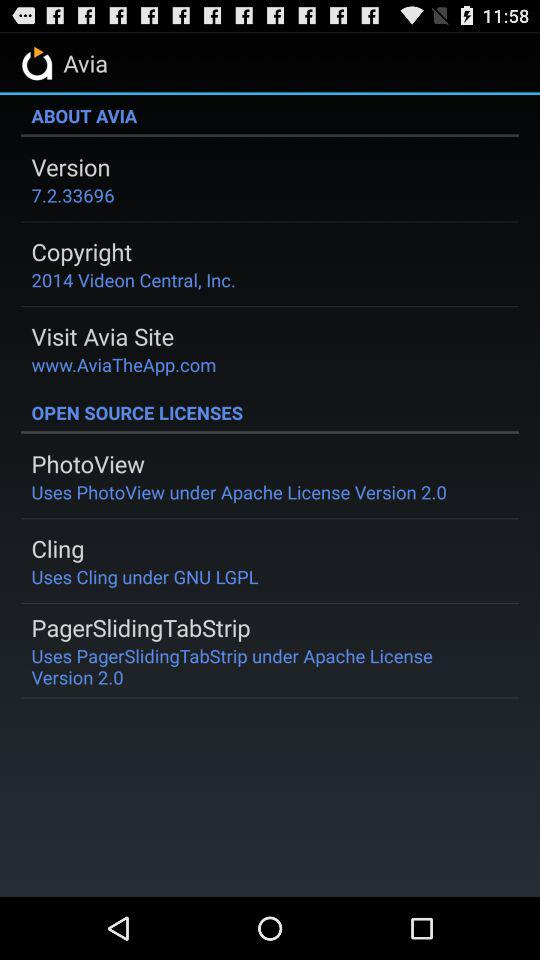What is the websit The website is "www.AviaTheApp.com". 